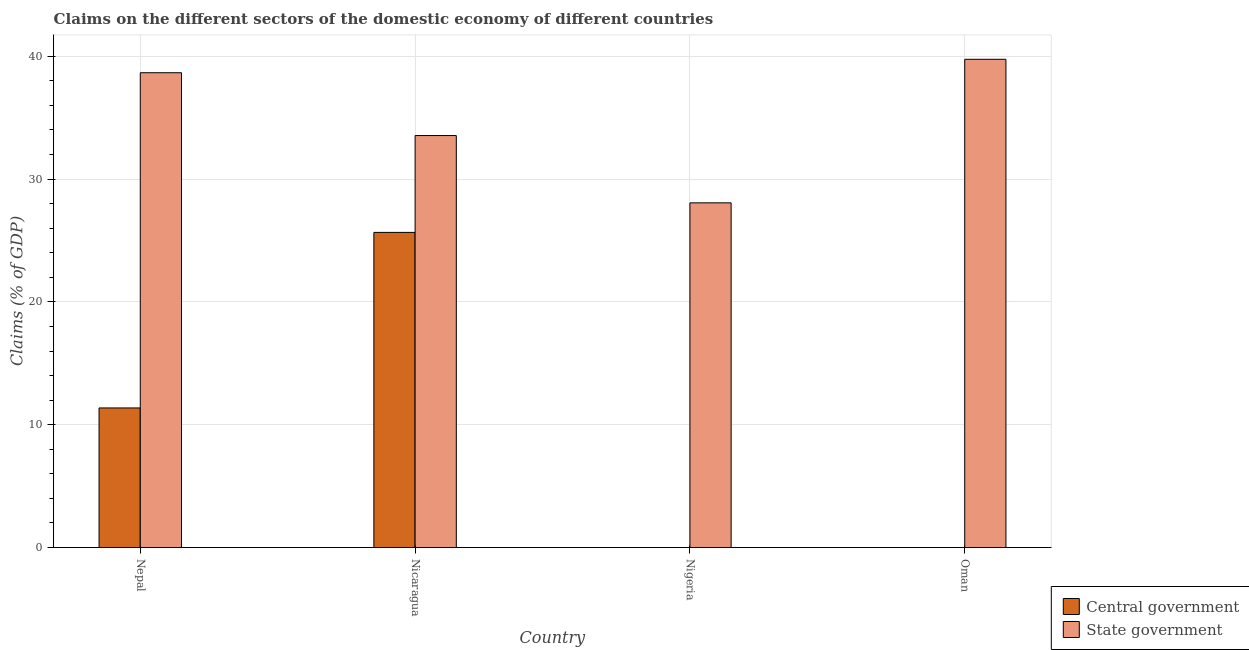How many different coloured bars are there?
Give a very brief answer. 2. Are the number of bars on each tick of the X-axis equal?
Offer a terse response. No. How many bars are there on the 1st tick from the left?
Offer a very short reply. 2. How many bars are there on the 2nd tick from the right?
Offer a terse response. 1. What is the label of the 1st group of bars from the left?
Give a very brief answer. Nepal. What is the claims on state government in Nigeria?
Keep it short and to the point. 28.06. Across all countries, what is the maximum claims on central government?
Ensure brevity in your answer.  25.66. Across all countries, what is the minimum claims on state government?
Ensure brevity in your answer.  28.06. In which country was the claims on state government maximum?
Keep it short and to the point. Oman. What is the total claims on state government in the graph?
Ensure brevity in your answer.  140.01. What is the difference between the claims on state government in Nepal and that in Oman?
Offer a terse response. -1.09. What is the difference between the claims on central government in Nicaragua and the claims on state government in Nigeria?
Give a very brief answer. -2.41. What is the average claims on state government per country?
Give a very brief answer. 35. What is the difference between the claims on central government and claims on state government in Nicaragua?
Your response must be concise. -7.88. In how many countries, is the claims on central government greater than 26 %?
Provide a short and direct response. 0. What is the ratio of the claims on state government in Nicaragua to that in Nigeria?
Give a very brief answer. 1.2. What is the difference between the highest and the second highest claims on state government?
Keep it short and to the point. 1.09. What is the difference between the highest and the lowest claims on state government?
Give a very brief answer. 11.69. In how many countries, is the claims on central government greater than the average claims on central government taken over all countries?
Offer a very short reply. 2. Are all the bars in the graph horizontal?
Provide a succinct answer. No. How many countries are there in the graph?
Offer a very short reply. 4. Does the graph contain any zero values?
Make the answer very short. Yes. How many legend labels are there?
Offer a terse response. 2. How are the legend labels stacked?
Keep it short and to the point. Vertical. What is the title of the graph?
Make the answer very short. Claims on the different sectors of the domestic economy of different countries. Does "Non-pregnant women" appear as one of the legend labels in the graph?
Keep it short and to the point. No. What is the label or title of the Y-axis?
Your answer should be compact. Claims (% of GDP). What is the Claims (% of GDP) in Central government in Nepal?
Ensure brevity in your answer.  11.36. What is the Claims (% of GDP) in State government in Nepal?
Ensure brevity in your answer.  38.66. What is the Claims (% of GDP) of Central government in Nicaragua?
Make the answer very short. 25.66. What is the Claims (% of GDP) of State government in Nicaragua?
Give a very brief answer. 33.54. What is the Claims (% of GDP) of Central government in Nigeria?
Offer a terse response. 0. What is the Claims (% of GDP) in State government in Nigeria?
Provide a short and direct response. 28.06. What is the Claims (% of GDP) in Central government in Oman?
Offer a terse response. 0. What is the Claims (% of GDP) in State government in Oman?
Give a very brief answer. 39.75. Across all countries, what is the maximum Claims (% of GDP) of Central government?
Provide a short and direct response. 25.66. Across all countries, what is the maximum Claims (% of GDP) in State government?
Your answer should be very brief. 39.75. Across all countries, what is the minimum Claims (% of GDP) of Central government?
Your answer should be compact. 0. Across all countries, what is the minimum Claims (% of GDP) in State government?
Keep it short and to the point. 28.06. What is the total Claims (% of GDP) in Central government in the graph?
Provide a succinct answer. 37.02. What is the total Claims (% of GDP) in State government in the graph?
Your answer should be very brief. 140.01. What is the difference between the Claims (% of GDP) of Central government in Nepal and that in Nicaragua?
Your response must be concise. -14.29. What is the difference between the Claims (% of GDP) in State government in Nepal and that in Nicaragua?
Provide a succinct answer. 5.12. What is the difference between the Claims (% of GDP) in State government in Nepal and that in Nigeria?
Provide a short and direct response. 10.59. What is the difference between the Claims (% of GDP) of State government in Nepal and that in Oman?
Your answer should be compact. -1.09. What is the difference between the Claims (% of GDP) of State government in Nicaragua and that in Nigeria?
Give a very brief answer. 5.48. What is the difference between the Claims (% of GDP) of State government in Nicaragua and that in Oman?
Offer a terse response. -6.21. What is the difference between the Claims (% of GDP) of State government in Nigeria and that in Oman?
Offer a terse response. -11.69. What is the difference between the Claims (% of GDP) in Central government in Nepal and the Claims (% of GDP) in State government in Nicaragua?
Your answer should be very brief. -22.18. What is the difference between the Claims (% of GDP) of Central government in Nepal and the Claims (% of GDP) of State government in Nigeria?
Give a very brief answer. -16.7. What is the difference between the Claims (% of GDP) in Central government in Nepal and the Claims (% of GDP) in State government in Oman?
Provide a succinct answer. -28.39. What is the difference between the Claims (% of GDP) in Central government in Nicaragua and the Claims (% of GDP) in State government in Nigeria?
Offer a very short reply. -2.41. What is the difference between the Claims (% of GDP) in Central government in Nicaragua and the Claims (% of GDP) in State government in Oman?
Offer a very short reply. -14.09. What is the average Claims (% of GDP) in Central government per country?
Ensure brevity in your answer.  9.26. What is the average Claims (% of GDP) of State government per country?
Provide a short and direct response. 35. What is the difference between the Claims (% of GDP) of Central government and Claims (% of GDP) of State government in Nepal?
Make the answer very short. -27.29. What is the difference between the Claims (% of GDP) in Central government and Claims (% of GDP) in State government in Nicaragua?
Make the answer very short. -7.88. What is the ratio of the Claims (% of GDP) of Central government in Nepal to that in Nicaragua?
Offer a terse response. 0.44. What is the ratio of the Claims (% of GDP) in State government in Nepal to that in Nicaragua?
Offer a very short reply. 1.15. What is the ratio of the Claims (% of GDP) of State government in Nepal to that in Nigeria?
Offer a very short reply. 1.38. What is the ratio of the Claims (% of GDP) of State government in Nepal to that in Oman?
Offer a very short reply. 0.97. What is the ratio of the Claims (% of GDP) in State government in Nicaragua to that in Nigeria?
Keep it short and to the point. 1.2. What is the ratio of the Claims (% of GDP) of State government in Nicaragua to that in Oman?
Make the answer very short. 0.84. What is the ratio of the Claims (% of GDP) in State government in Nigeria to that in Oman?
Offer a terse response. 0.71. What is the difference between the highest and the second highest Claims (% of GDP) of State government?
Keep it short and to the point. 1.09. What is the difference between the highest and the lowest Claims (% of GDP) of Central government?
Provide a short and direct response. 25.66. What is the difference between the highest and the lowest Claims (% of GDP) in State government?
Give a very brief answer. 11.69. 